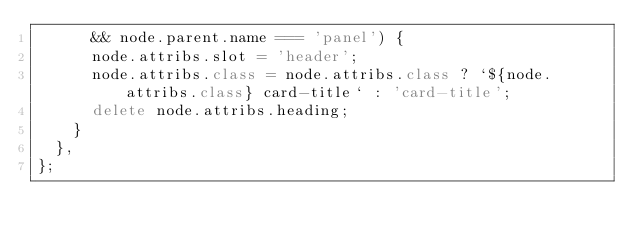<code> <loc_0><loc_0><loc_500><loc_500><_JavaScript_>      && node.parent.name === 'panel') {
      node.attribs.slot = 'header';
      node.attribs.class = node.attribs.class ? `${node.attribs.class} card-title` : 'card-title';
      delete node.attribs.heading;
    }
  },
};
</code> 